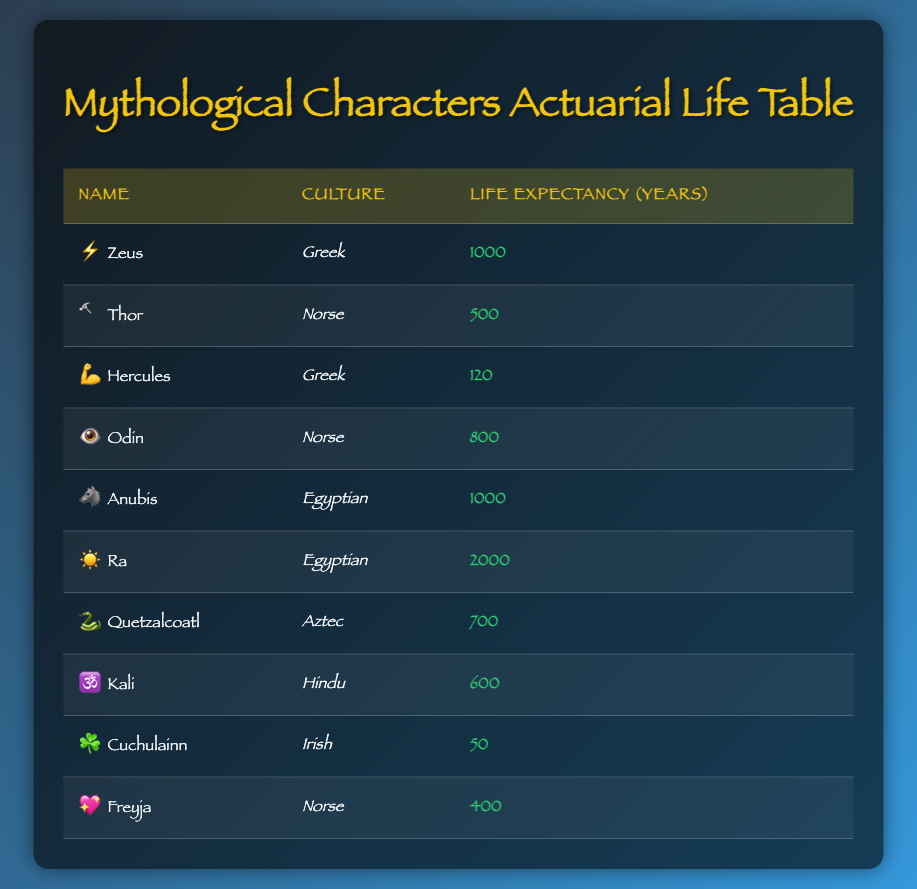What is the life expectancy of Zeus? The life expectancy for Zeus is listed directly in the table under "Life Expectancy (years)" next to his name. It shows that his life expectancy is 1000 years.
Answer: 1000 Which character has the highest life expectancy? By examining the life expectancy values in the table, we see that Ra has the highest life expectancy of 2000 years, which is noted in the corresponding row for Ra.
Answer: 2000 How many mythological characters have a life expectancy over 500 years? To determine this, we count all characters whose life expectancy is greater than 500 years. Checking the table, we find that Zeus (1000), Anubis (1000), Ra (2000), Odin (800), and Quetzalcoatl (700) all have life expectancies over 500, totaling five characters.
Answer: 5 Is Hercules the only Greek character in the list with a life expectancy below 100 years? We verify the table for Greek characters: Zeus (1000) and Hercules (120). Since Hercules is the only Greek character listed with a life expectancy below 100 years, the statement is true.
Answer: Yes What is the average life expectancy of the Norse characters? We first identify the Norse characters from the table: Thor (500), Odin (800), and Freyja (400). Next, we add their life expectancies: 500 + 800 + 400 = 1700. Then, we divide by the number of characters, which is 3, so the average is 1700 / 3 = approximately 566.67.
Answer: Approximately 566.67 Compare the life expectancy of Egyptian characters to that of Irish characters. Who has a higher average? The Egyptian characters are Anubis (1000) and Ra (2000), giving an average of (1000 + 2000) / 2 = 1500. The Irish character is Cuchulainn (50), with a single value of 50 for average. Therefore, we see that Egyptian characters have a higher average life expectancy than Irish characters.
Answer: Egyptian characters are higher What is the total life expectancy of all characters from Aztec and Hindu cultures? In the table, the Aztec character is Quetzalcoatl (700), and the Hindu character is Kali (600). To find the total, we sum these life expectancies: 700 + 600 = 1300.
Answer: 1300 Does any character have the same life expectancy as Ra? The table shows that Ra has a life expectancy of 2000 years. Checking each character in the table, we find that no other character has a life expectancy equal to Ra's, so the statement is false.
Answer: No 